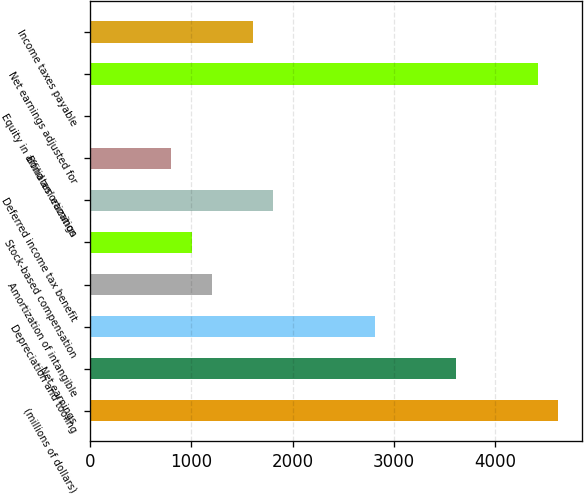Convert chart to OTSL. <chart><loc_0><loc_0><loc_500><loc_500><bar_chart><fcel>(millions of dollars)<fcel>Net earnings<fcel>Depreciation and tooling<fcel>Amortization of intangible<fcel>Stock-based compensation<fcel>Deferred income tax benefit<fcel>Bond amortization<fcel>Equity in affiliates' earnings<fcel>Net earnings adjusted for<fcel>Income taxes payable<nl><fcel>4620.79<fcel>3616.64<fcel>2813.32<fcel>1206.68<fcel>1005.85<fcel>1809.17<fcel>805.02<fcel>1.7<fcel>4419.96<fcel>1608.34<nl></chart> 